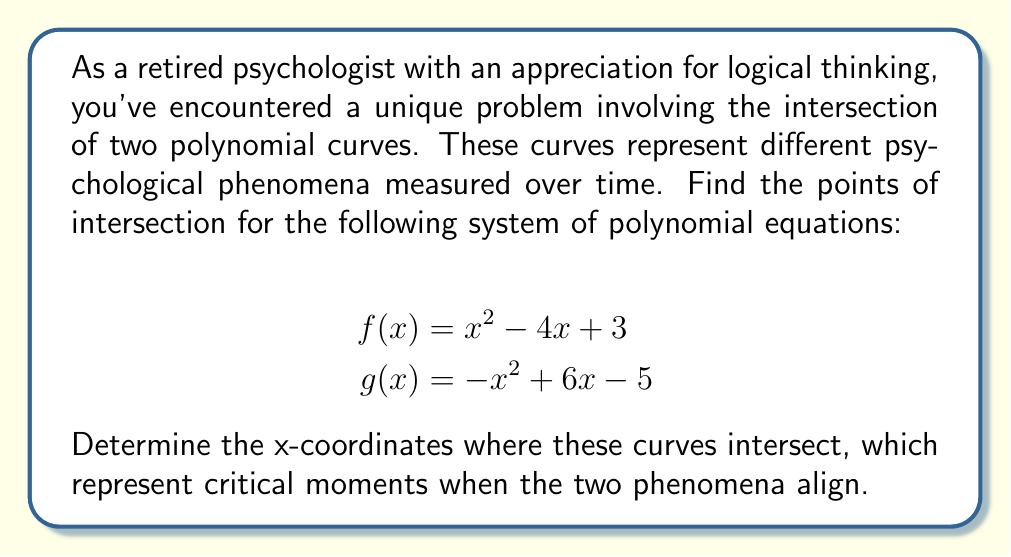Can you answer this question? Let's approach this step-by-step:

1) To find the intersection points, we need to set the two equations equal to each other:

   $$x^2 - 4x + 3 = -x^2 + 6x - 5$$

2) Rearrange the equation so that all terms are on one side:

   $$x^2 - 4x + 3 + x^2 - 6x + 5 = 0$$

3) Simplify:

   $$2x^2 - 10x + 8 = 0$$

4) Divide all terms by 2 to simplify further:

   $$x^2 - 5x + 4 = 0$$

5) This is a quadratic equation. We can solve it using the quadratic formula:

   $$x = \frac{-b \pm \sqrt{b^2 - 4ac}}{2a}$$

   Where $a = 1$, $b = -5$, and $c = 4$

6) Substitute these values:

   $$x = \frac{5 \pm \sqrt{25 - 16}}{2} = \frac{5 \pm \sqrt{9}}{2} = \frac{5 \pm 3}{2}$$

7) This gives us two solutions:

   $$x_1 = \frac{5 + 3}{2} = 4$$
   $$x_2 = \frac{5 - 3}{2} = 1$$

Therefore, the curves intersect at $x = 1$ and $x = 4$.
Answer: $x = 1$ and $x = 4$ 